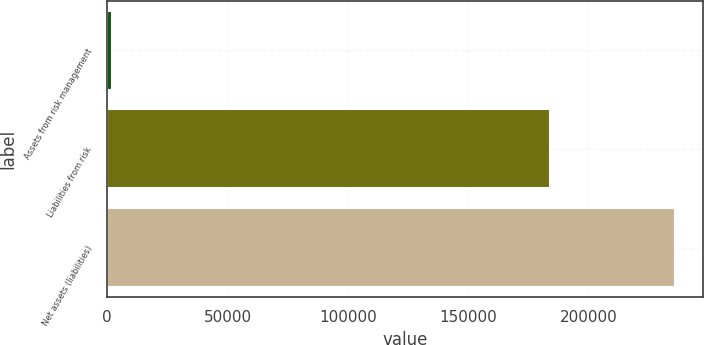Convert chart to OTSL. <chart><loc_0><loc_0><loc_500><loc_500><bar_chart><fcel>Assets from risk management<fcel>Liabilities from risk<fcel>Net assets (liabilities)<nl><fcel>1822<fcel>184048<fcel>235968<nl></chart> 